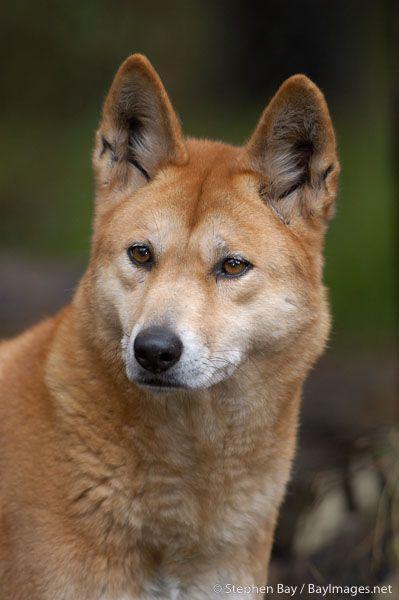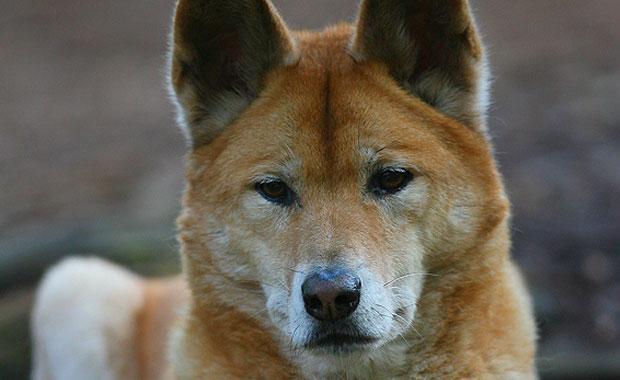The first image is the image on the left, the second image is the image on the right. For the images shown, is this caption "At least one image includes a dog standing with head facing the camera." true? Answer yes or no. No. The first image is the image on the left, the second image is the image on the right. Assess this claim about the two images: "The background of the image on the left is brown". Correct or not? Answer yes or no. No. 